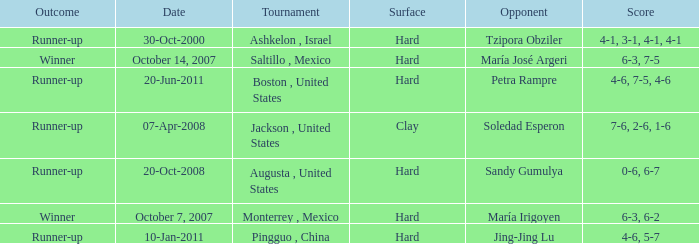Which tournament was held on October 14, 2007? Saltillo , Mexico. 